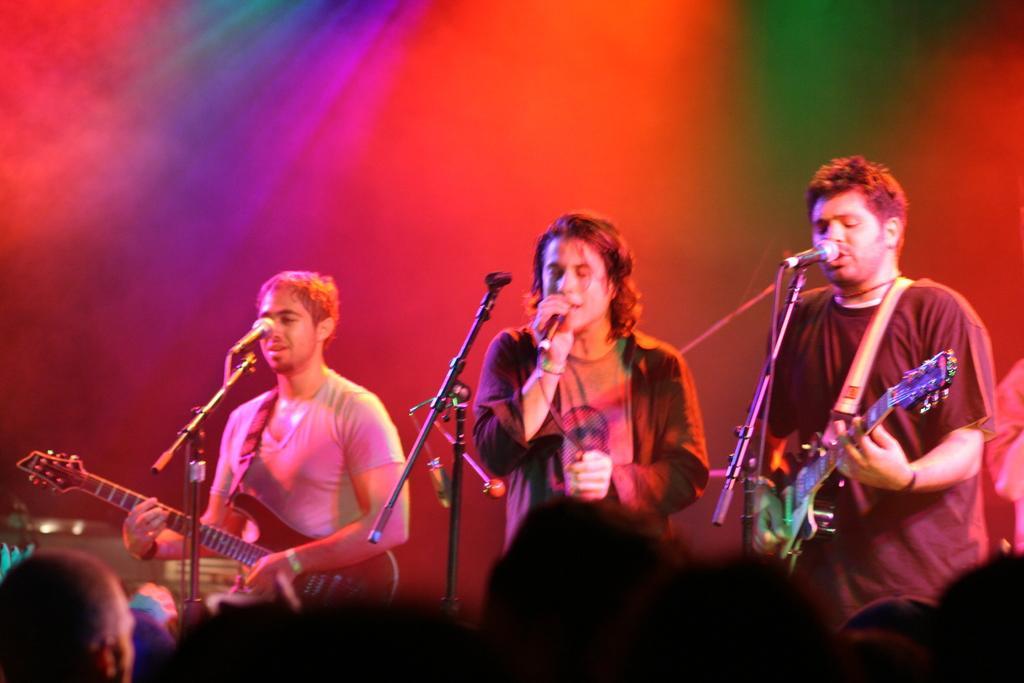Could you give a brief overview of what you see in this image? In this image I can see few people are standing and also few of them are holding guitars. Here I can see he is holding a mic and I can also see mics in front of them. 